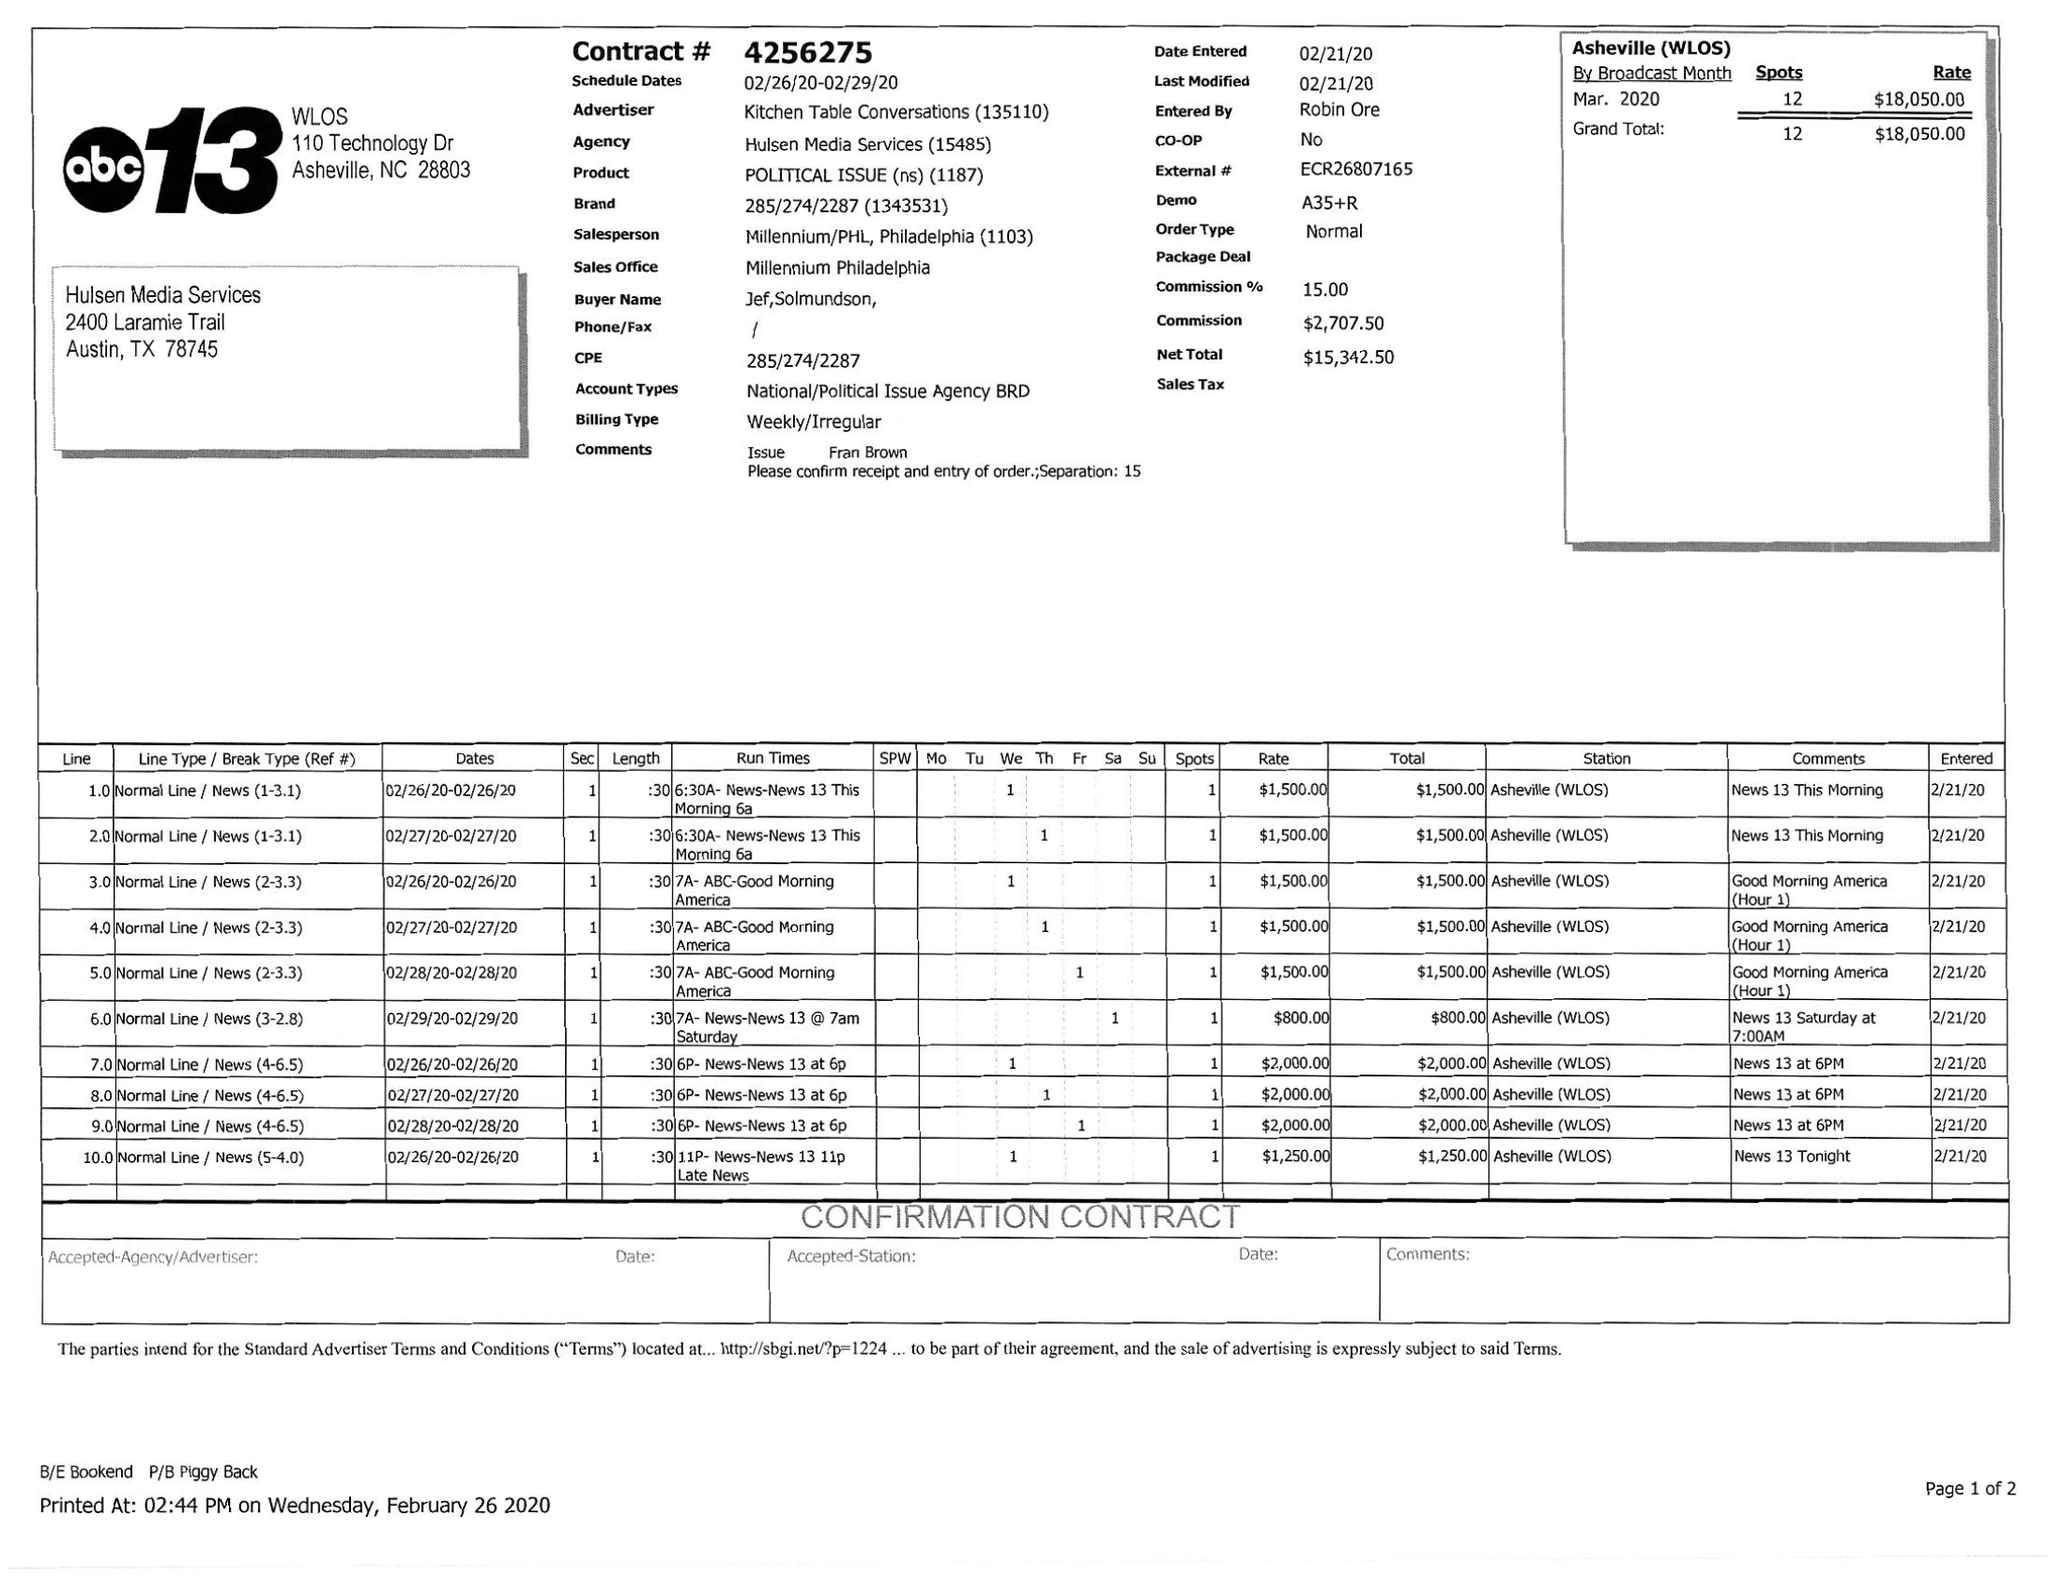What is the value for the gross_amount?
Answer the question using a single word or phrase. 18050.00 